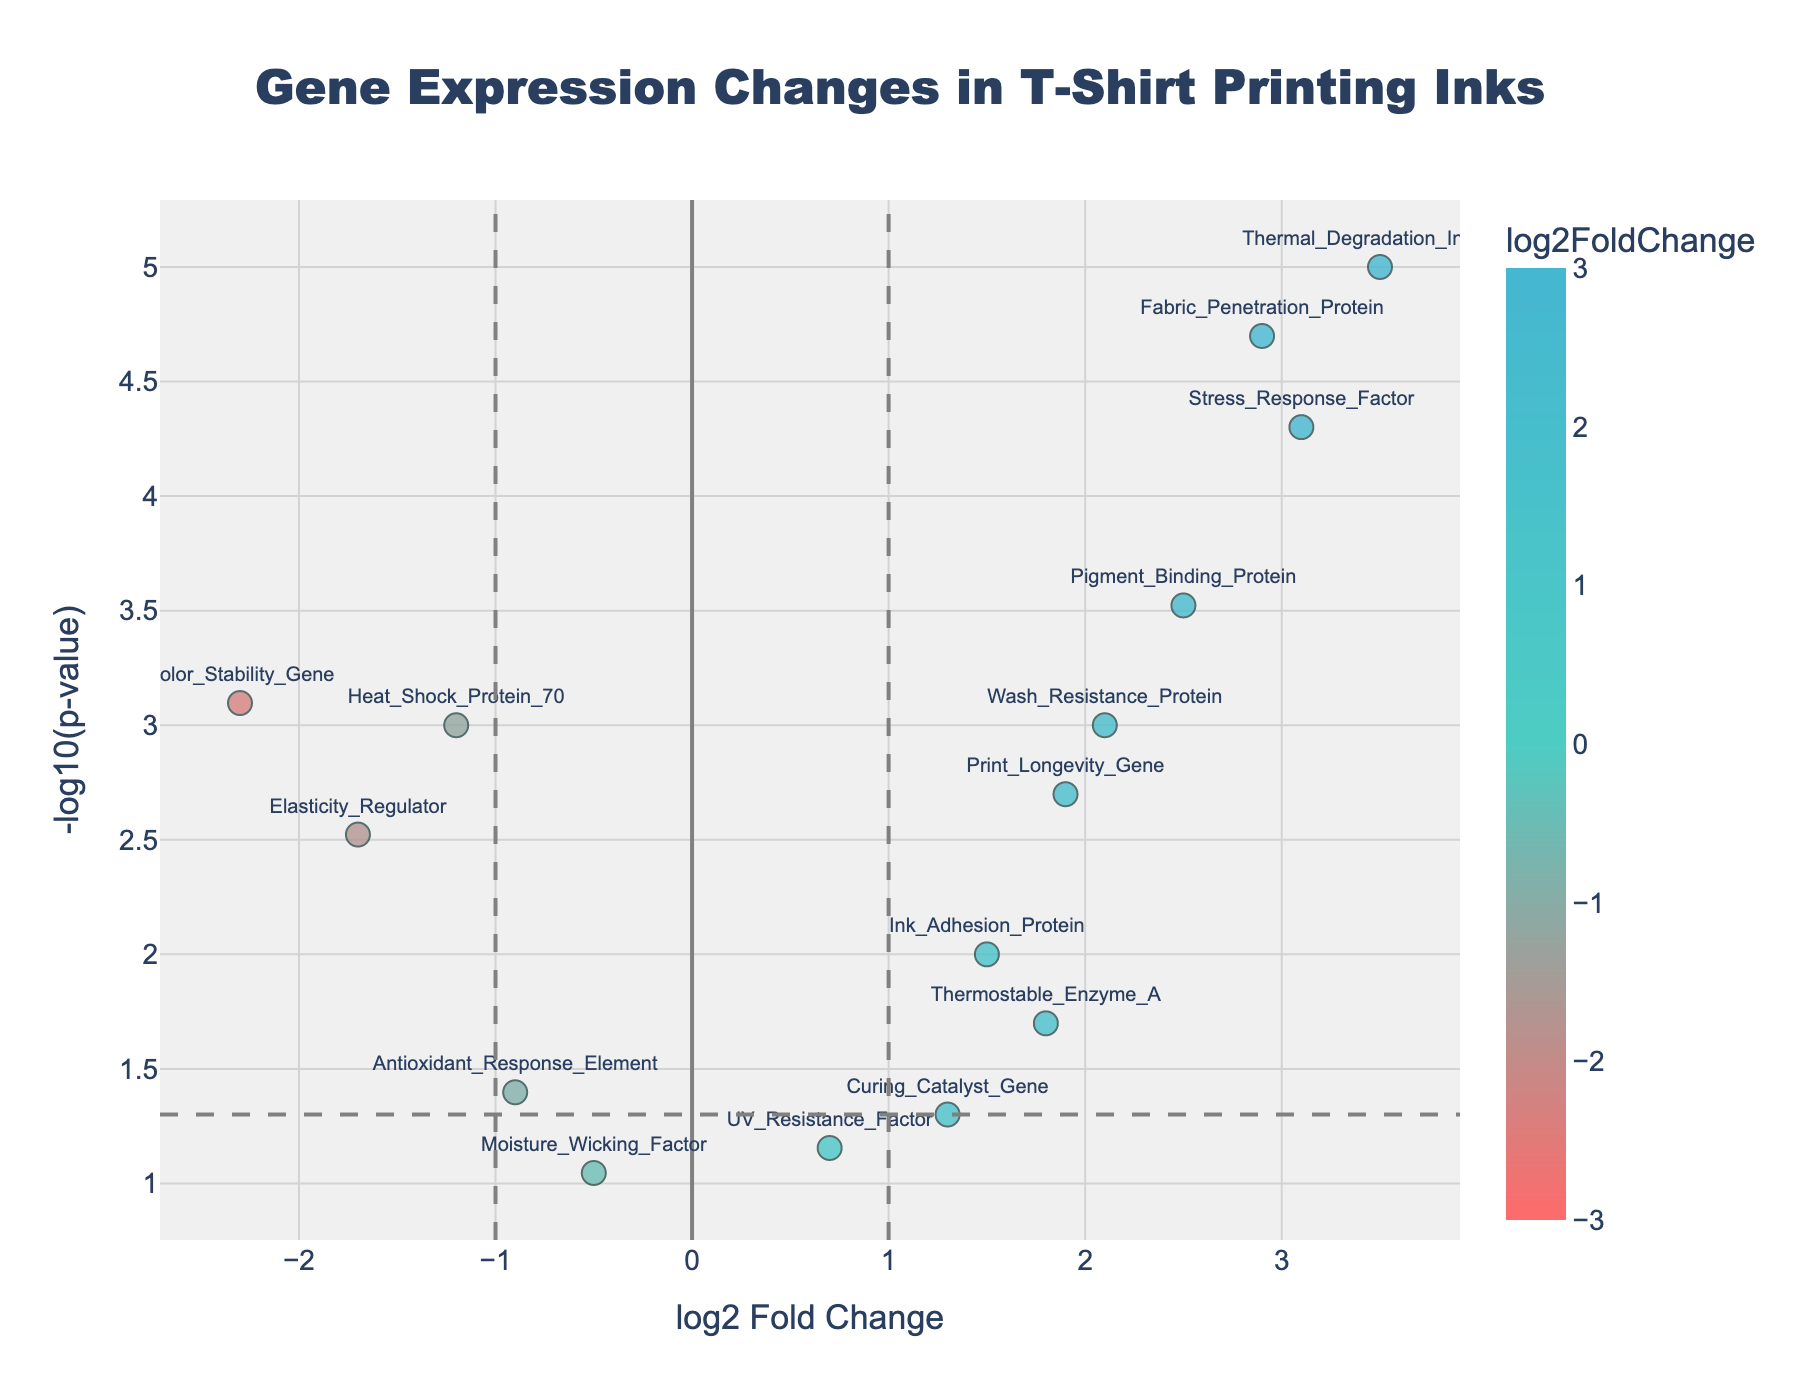What's the title of the plot? The plot's title is usually located at the top center of the figure. Here, the title can be found in bold letters in the middle at the top.
Answer: Gene Expression Changes in T-Shirt Printing Inks What does the x-axis represent? The x-axis label is located along the bottom horizontal line of the figure. It shows what the variable measured on the x-axis is.
Answer: log2 Fold Change What does the y-axis represent? The y-axis label is located along the left vertical line of the figure. It indicates the variable measured on the y-axis.
Answer: -log10(p-value) Which gene shows the highest log2 fold change? To find this, look for the data point furthest to the right on the plot. The gene label next to this marker will indicate which gene it is.
Answer: Thermal_Degradation_Inhibitor How many genes have a log2 fold change greater than 1? Identify genes on the plot that are located to the right of the vertical threshold line at log2 fold change = 1. Count these points.
Answer: 7 Which gene has the smallest p-value? In a volcano plot, the smallest p-value corresponds to the highest -log10(p-value). Look for the point at the top of the plot.
Answer: Thermal_Degradation_Inhibitor How many genes are significantly upregulated with p-value < 0.05 and log2 fold change > 1? Look for the points above the horizontal threshold line at -log10(p-value) = -log10(0.05) and to the right of the vertical threshold at log2 fold change = 1. Count these points.
Answer: 6 Which gene has the most extreme negative log2 fold change? Identify the data point furthest to the left on the plot. The gene label next to it will tell you which gene it is.
Answer: Color_Stability_Gene Compare Fabric_Penetration_Protein and Print_Longevity_Gene: which has a higher -log10(p-value)? Locate both genes on the plot. The one positioned higher on the y-axis has the higher -log10(p-value).
Answer: Fabric_Penetration_Protein 